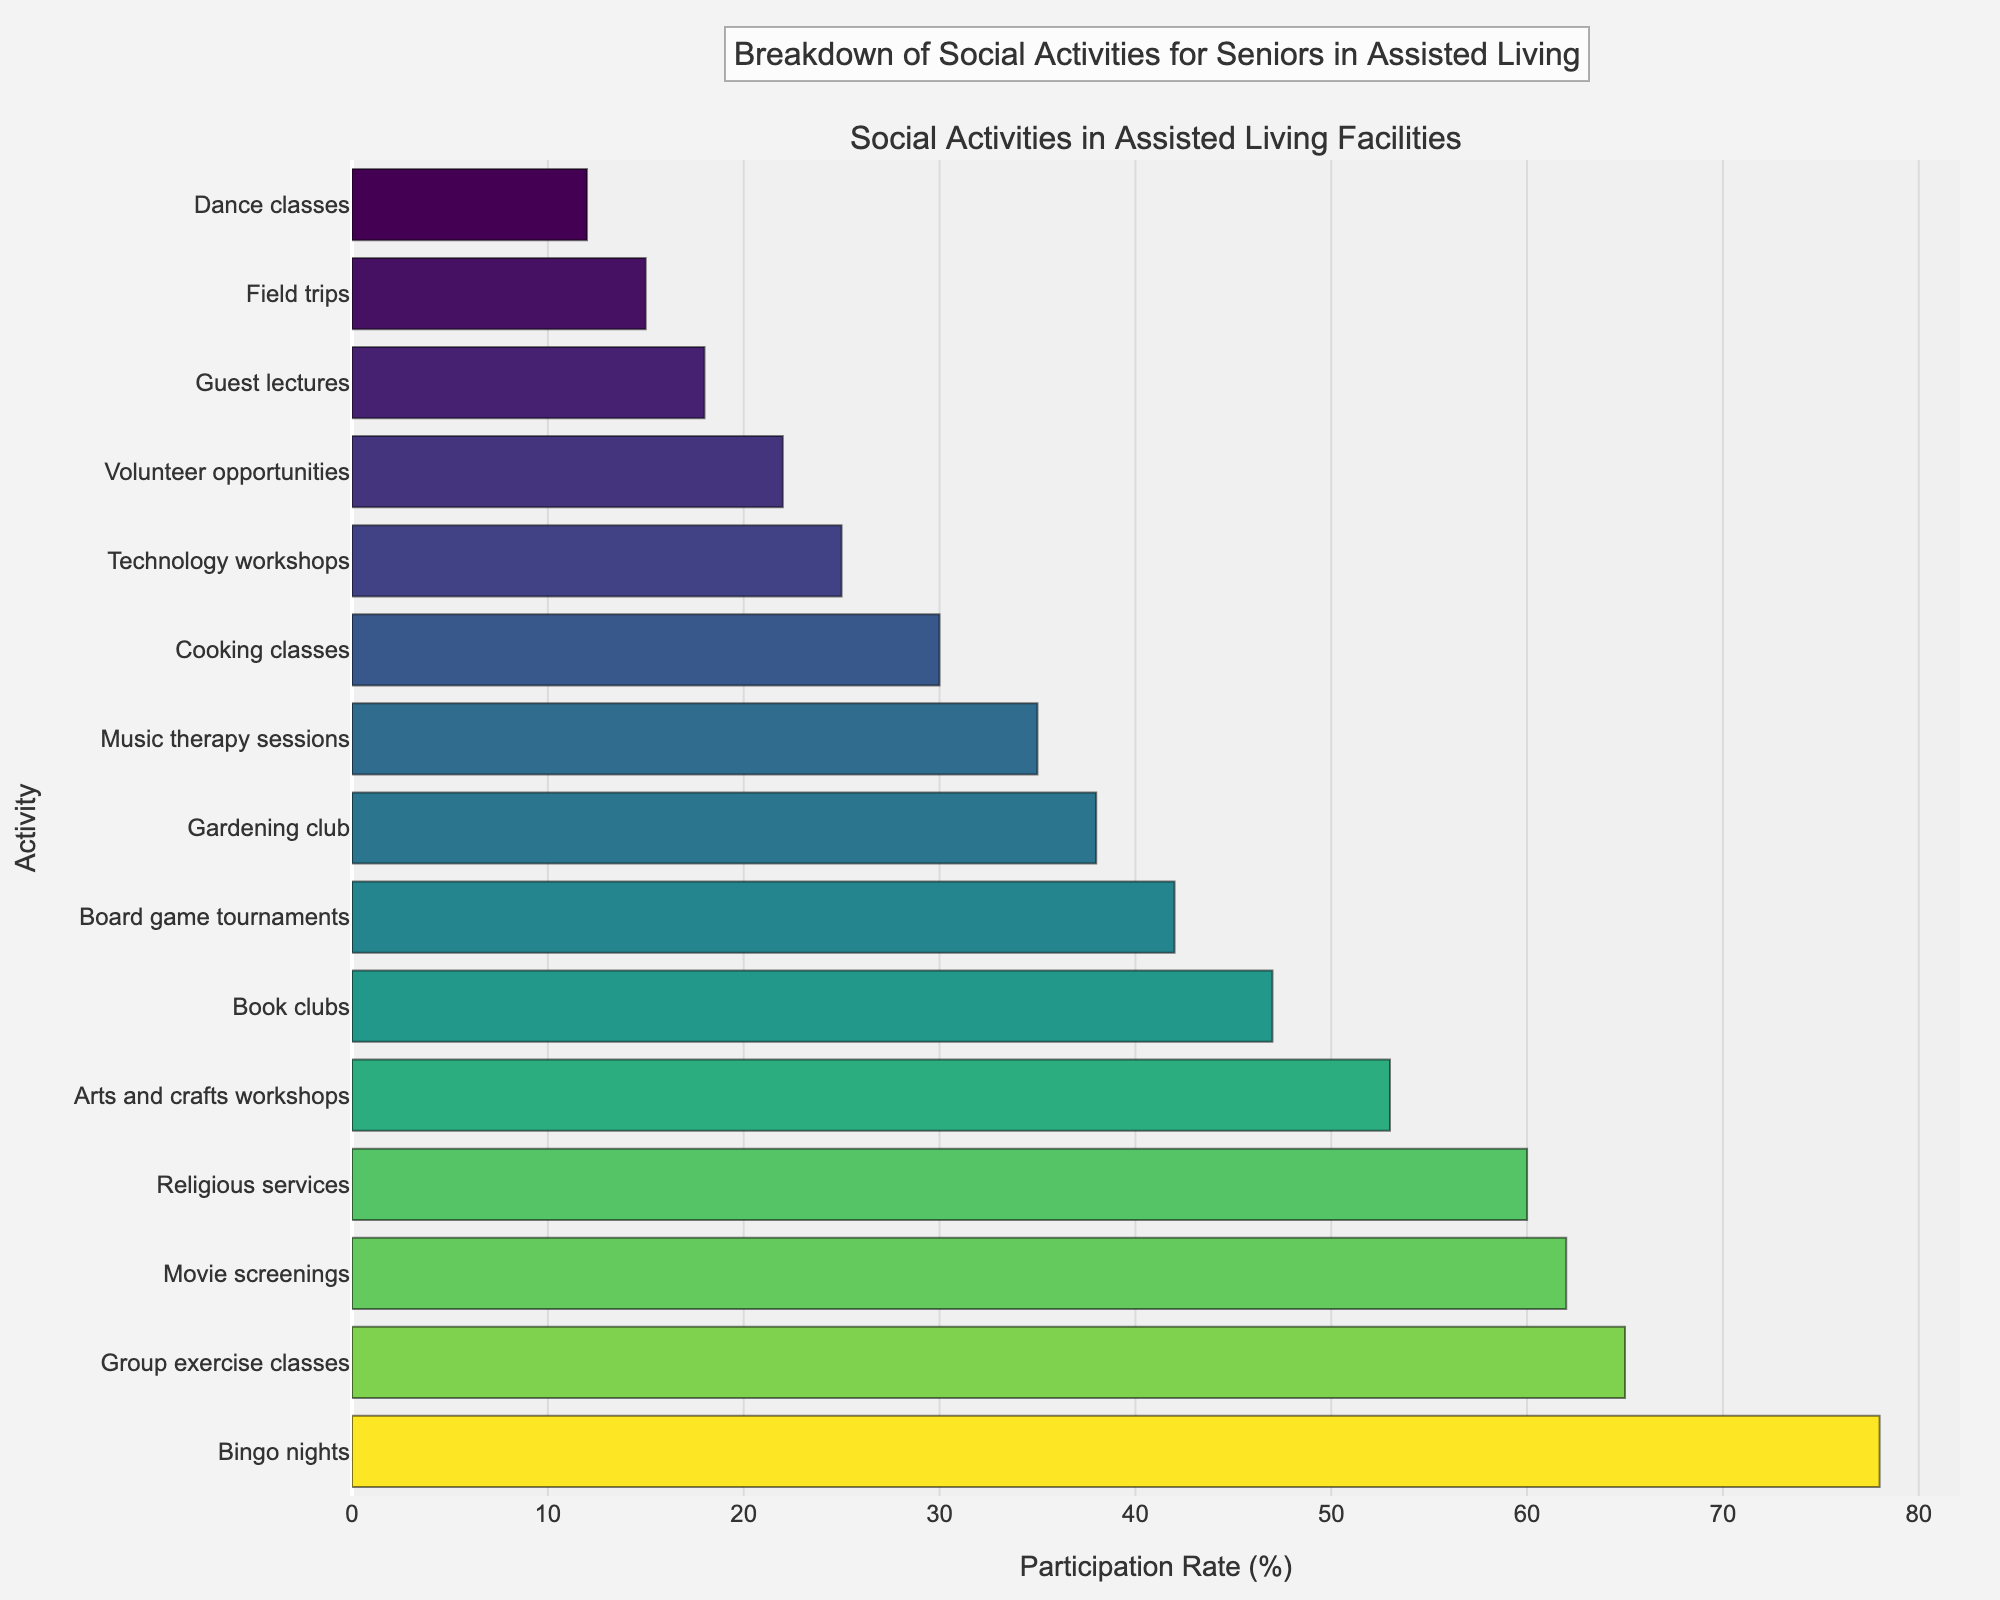Which social activity has the highest participation rate? Compare the lengths of the bars; the longest bar represents the activity with the highest participation rate. The longest bar is for "Bingo nights" with a 78% participation rate.
Answer: Bingo nights What is the participation difference between the highest and lowest activities? Identify the percentages for the highest (78% for Bingo nights) and lowest (12% for Dance classes) activities and subtract the latter from the former: 78% - 12% = 66%.
Answer: 66% Which activities have a participation rate of over 60%? Look for bars where the percentage is greater than 60%. The activities are Bingo nights (78%), Group exercise classes (65%), and Religious services (60%).
Answer: Bingo nights, Group exercise classes, Religious services How many activities have a participation rate of less than 30%? Count the bars where the percentage is less than 30%. The activities are Cooking classes (30%), Technology workshops (25%), Volunteer opportunities (22%), Guest lectures (18%), Field trips (15%), and Dance classes (12%). There are 6 such activities.
Answer: 6 What is the average participation rate of the top three activities? Identify the percentages for the top three activities (Bingo nights 78%, Group exercise classes 65%, Religious services 60%), sum them (78 + 65 + 60 = 203), and divide by 3: 203/3 ≈ 67.67%.
Answer: 67.67% Which activity has a higher participation rate: Arts and crafts workshops or Movie screenings? Compare the lengths of the bars for Arts and crafts workshops (53%) and Movie screenings (62%). Movie screenings have a higher participation rate.
Answer: Movie screenings What is the sum of the participation rates for board game tournaments and gardening club? Identify the percentages for Board game tournaments (42%) and Gardening club (38%) and sum them: 42% + 38% = 80%.
Answer: 80% What percentage of activities have a participation rate above 50%? Count the number of activities with a participation rate greater than 50% (Bingo nights, Group exercise classes, Movie screenings, Religious services, and Arts and crafts workshops). There are 5 such activities out of 15 total. Calculate the percentage: (5/15) * 100 ≈ 33.33%.
Answer: 33.33% Which activities are least and most popular given their color on the bar chart? Visually inspect the color gradient in the chart. The activity with the darkest color (most intense) is Bingo nights (78%), making it the most popular, and the one with the lightest color is Dance classes (12%), making it the least popular.
Answer: Bingo nights, Dance classes What is the median participation rate of all the activities? Arrange the participation percentages in ascending order and find the middle value. The ordered percentages are 12, 15, 18, 22, 25, 30, 35, 38, 42, 47, 53, 60, 62, 65, 78. The middle value (8th entry) is 38%.
Answer: 38% 